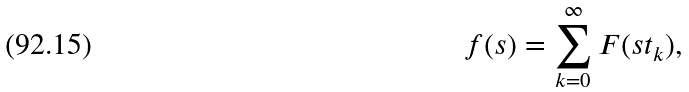<formula> <loc_0><loc_0><loc_500><loc_500>f ( s ) = \sum _ { k = 0 } ^ { \infty } F ( s t _ { k } ) ,</formula> 